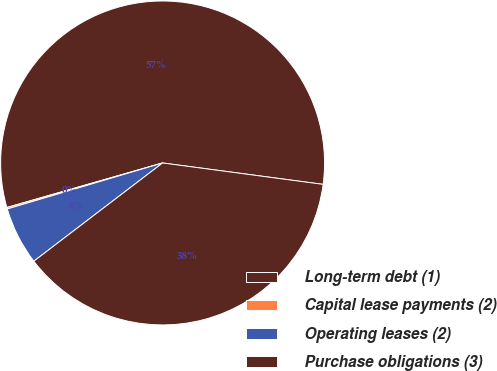Convert chart. <chart><loc_0><loc_0><loc_500><loc_500><pie_chart><fcel>Long-term debt (1)<fcel>Capital lease payments (2)<fcel>Operating leases (2)<fcel>Purchase obligations (3)<nl><fcel>56.55%<fcel>0.15%<fcel>5.79%<fcel>37.52%<nl></chart> 